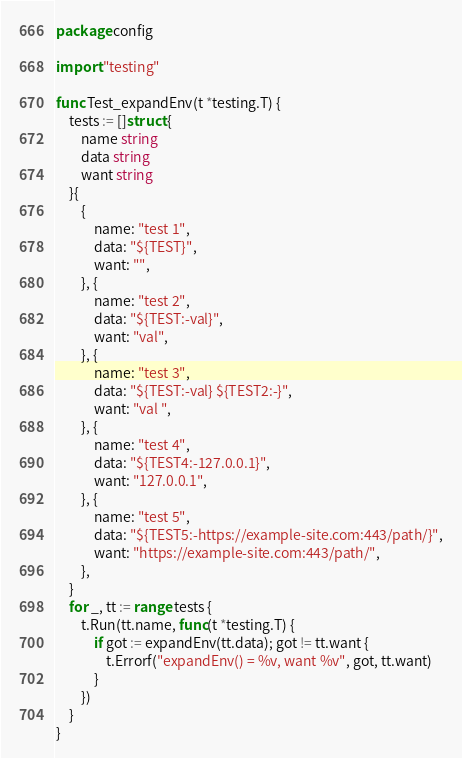Convert code to text. <code><loc_0><loc_0><loc_500><loc_500><_Go_>package config

import "testing"

func Test_expandEnv(t *testing.T) {
	tests := []struct {
		name string
		data string
		want string
	}{
		{
			name: "test 1",
			data: "${TEST}",
			want: "",
		}, {
			name: "test 2",
			data: "${TEST:-val}",
			want: "val",
		}, {
			name: "test 3",
			data: "${TEST:-val} ${TEST2:-}",
			want: "val ",
		}, {
			name: "test 4",
			data: "${TEST4:-127.0.0.1}",
			want: "127.0.0.1",
		}, {
			name: "test 5",
			data: "${TEST5:-https://example-site.com:443/path/}",
			want: "https://example-site.com:443/path/",
		},
	}
	for _, tt := range tests {
		t.Run(tt.name, func(t *testing.T) {
			if got := expandEnv(tt.data); got != tt.want {
				t.Errorf("expandEnv() = %v, want %v", got, tt.want)
			}
		})
	}
}
</code> 